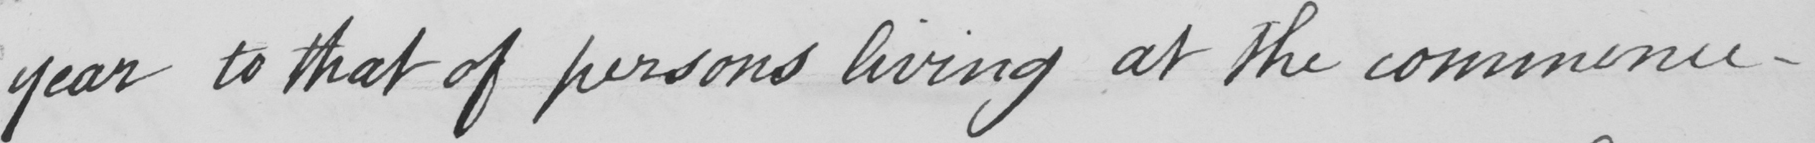What text is written in this handwritten line? year to that of persons living at the commence- 